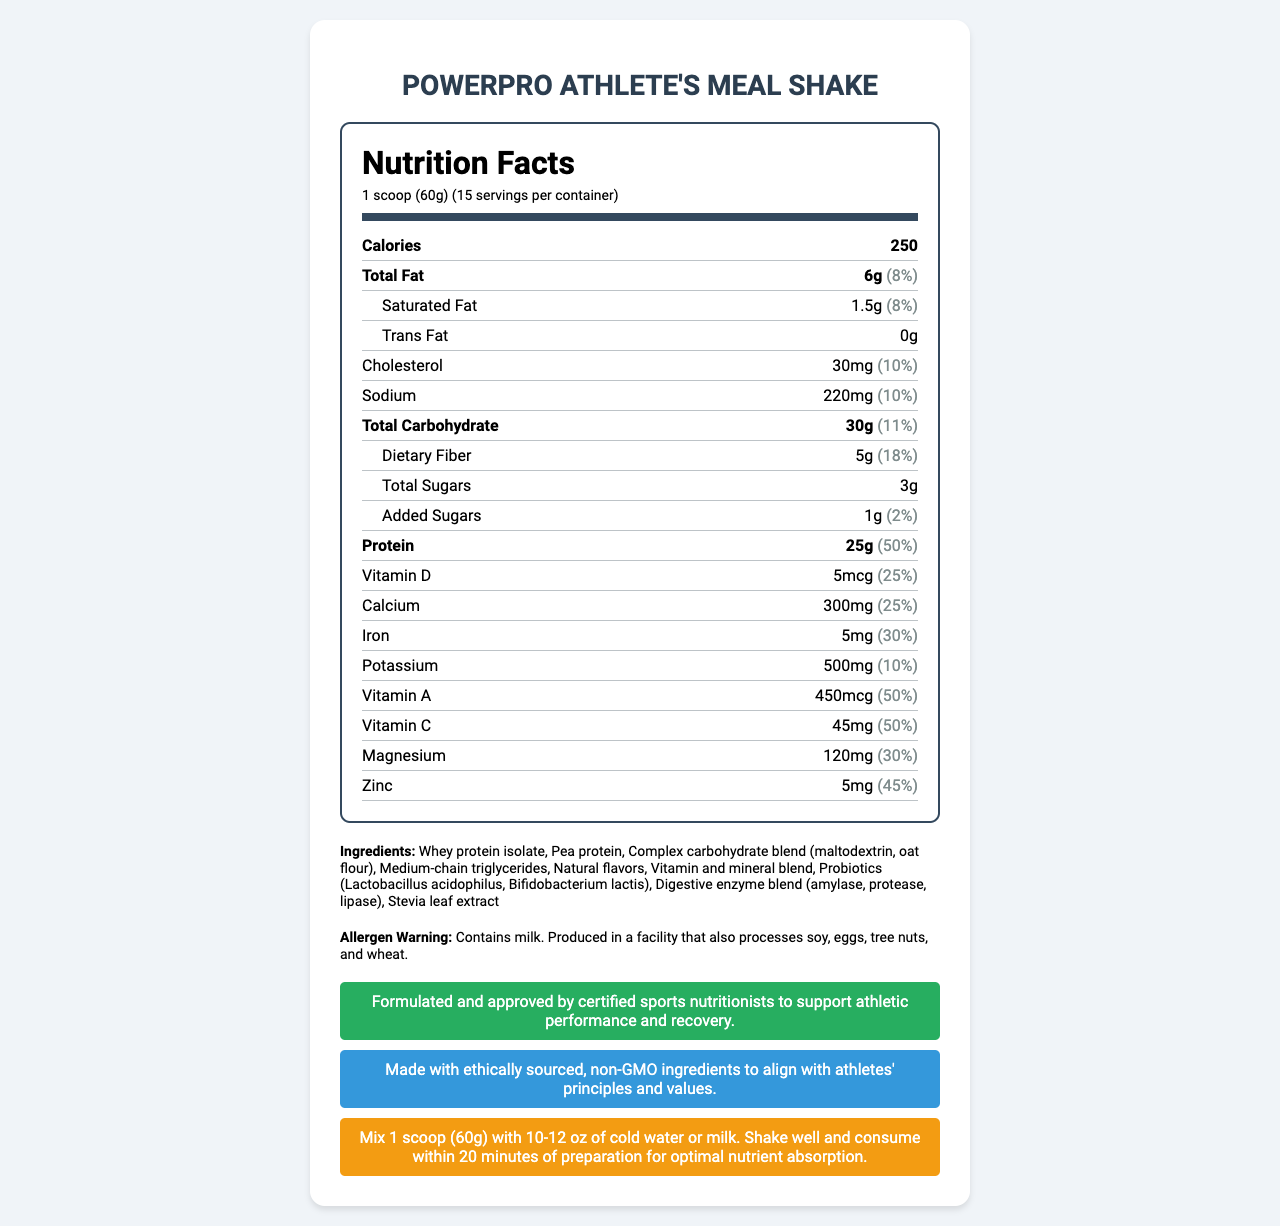How much protein does one serving contain? The document states under the "Nutrition Facts" section that the amount of protein per serving is 25g.
Answer: 25g What is the serving size of the PowerPro Athlete's Meal Shake? The serving size is listed at the very top of the "Nutrition Facts" section as "1 scoop (60g)".
Answer: 1 scoop (60g) What is the total number of calories per serving? The "Nutrition Facts" section lists calories at the top, stating that one serving contains 250 calories.
Answer: 250 calories What percentage of the Daily Value for dietary fiber does one serving contribute? The "Nutrition Facts" section lists that the daily value percentage for dietary fiber per serving is 18%.
Answer: 18% List three main sources of protein in this meal replacement shake. The "Ingredients" section includes Whey protein isolate and Pea protein as the primary sources of protein.
Answer: Whey protein isolate, Pea protein Which vitamin provides 50% of the Daily Value per serving? A. Vitamin D B. Vitamin A C. Vitamin C The document lists Vitamin C as providing 50% of the Daily Value per serving under the "Nutrition Facts" section.
Answer: C Which of the following is NOT an ingredient in PowerPro Athlete's Meal Shake? A. Natural flavors B. Soy protein C. Stevia leaf extract The "Ingredients" section does not list Soy protein as an ingredient; it lists Whey protein isolate and Pea protein instead.
Answer: B Does the PowerPro Athlete's Meal Shake contain trans fat? The document explicitly mentions that the Trans Fat amount is "0g".
Answer: No Is this product suitable for someone with a tree nut allergy? The "Allergen Warning" states that it's produced in a facility that processes tree nuts.
Answer: No Summarize the main idea of the PowerPro Athlete's Meal Shake document. The document extensively details nutritional information, ingredients, allergen warnings, and additional claims for the "PowerPro Athlete's Meal Shake", designed to support athletic performance and recovery.
Answer: This document provides detailed nutritional facts of the "PowerPro Athlete's Meal Shake", a balanced meal replacement shake formulated to meet athletes' nutritional needs. It lists serving size, calorie count, macronutrient details, and micronutrient values. The document also includes ingredient information, allergen warnings, and preparation instructions, emphasizing ethical sourcing and approval by sports nutritionists. What is the calorie content from fat in one serving? The document provides total calorie content and total fat quantity but doesn't explicitly state the number of calories derived from fat.
Answer: Cannot be determined 